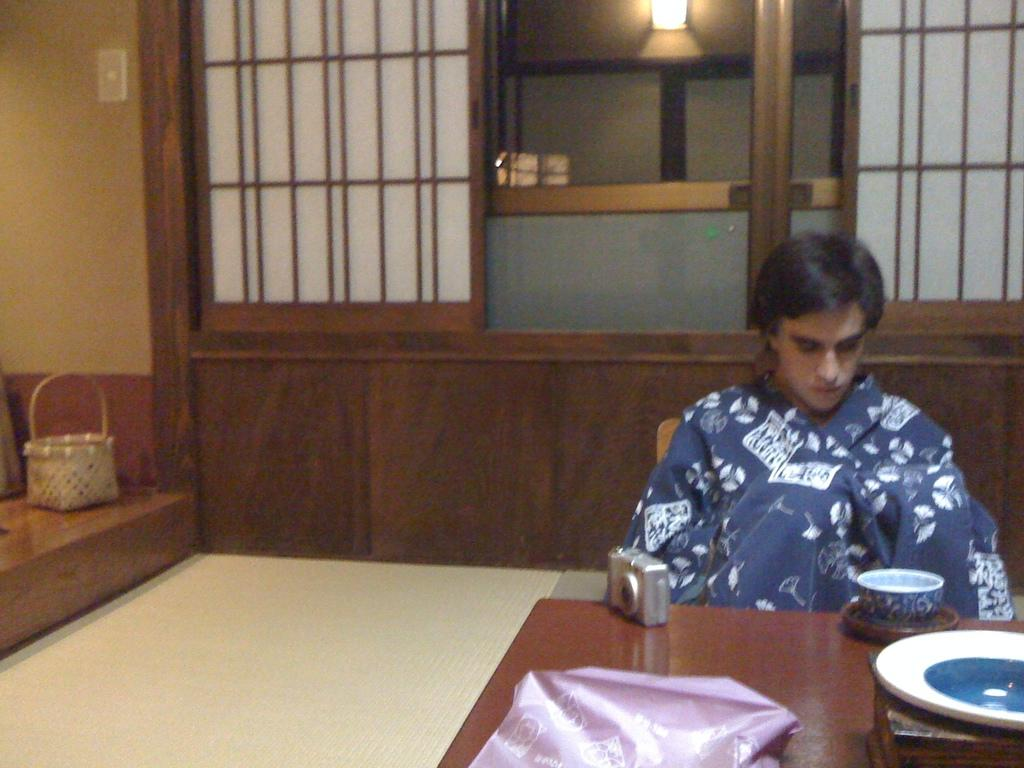What is the person in the image doing? The person is sitting on a chair in the image. What objects are on the table in the image? There is a cup and a camera on the table in the image. What can be seen in the background of the image? There is a basket in the background of the image. What type of stomach ache is the person experiencing in the image? There is no indication in the image that the person is experiencing a stomach ache. Can you tell me how many seashores are visible in the image? There are no seashores visible in the image. 